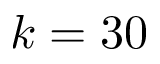Convert formula to latex. <formula><loc_0><loc_0><loc_500><loc_500>k = 3 0</formula> 